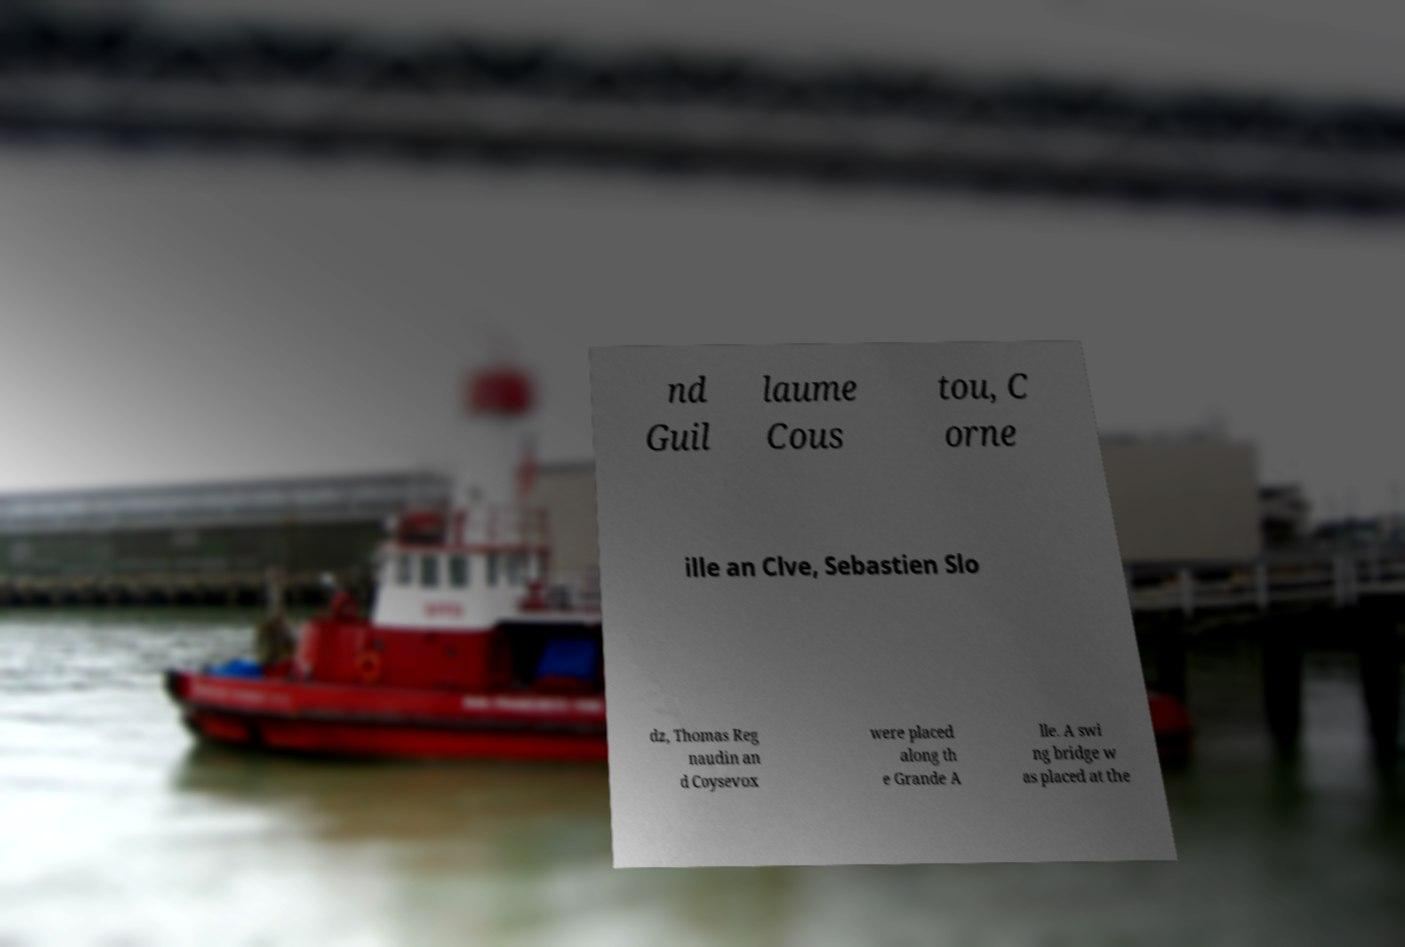There's text embedded in this image that I need extracted. Can you transcribe it verbatim? nd Guil laume Cous tou, C orne ille an Clve, Sebastien Slo dz, Thomas Reg naudin an d Coysevox were placed along th e Grande A lle. A swi ng bridge w as placed at the 